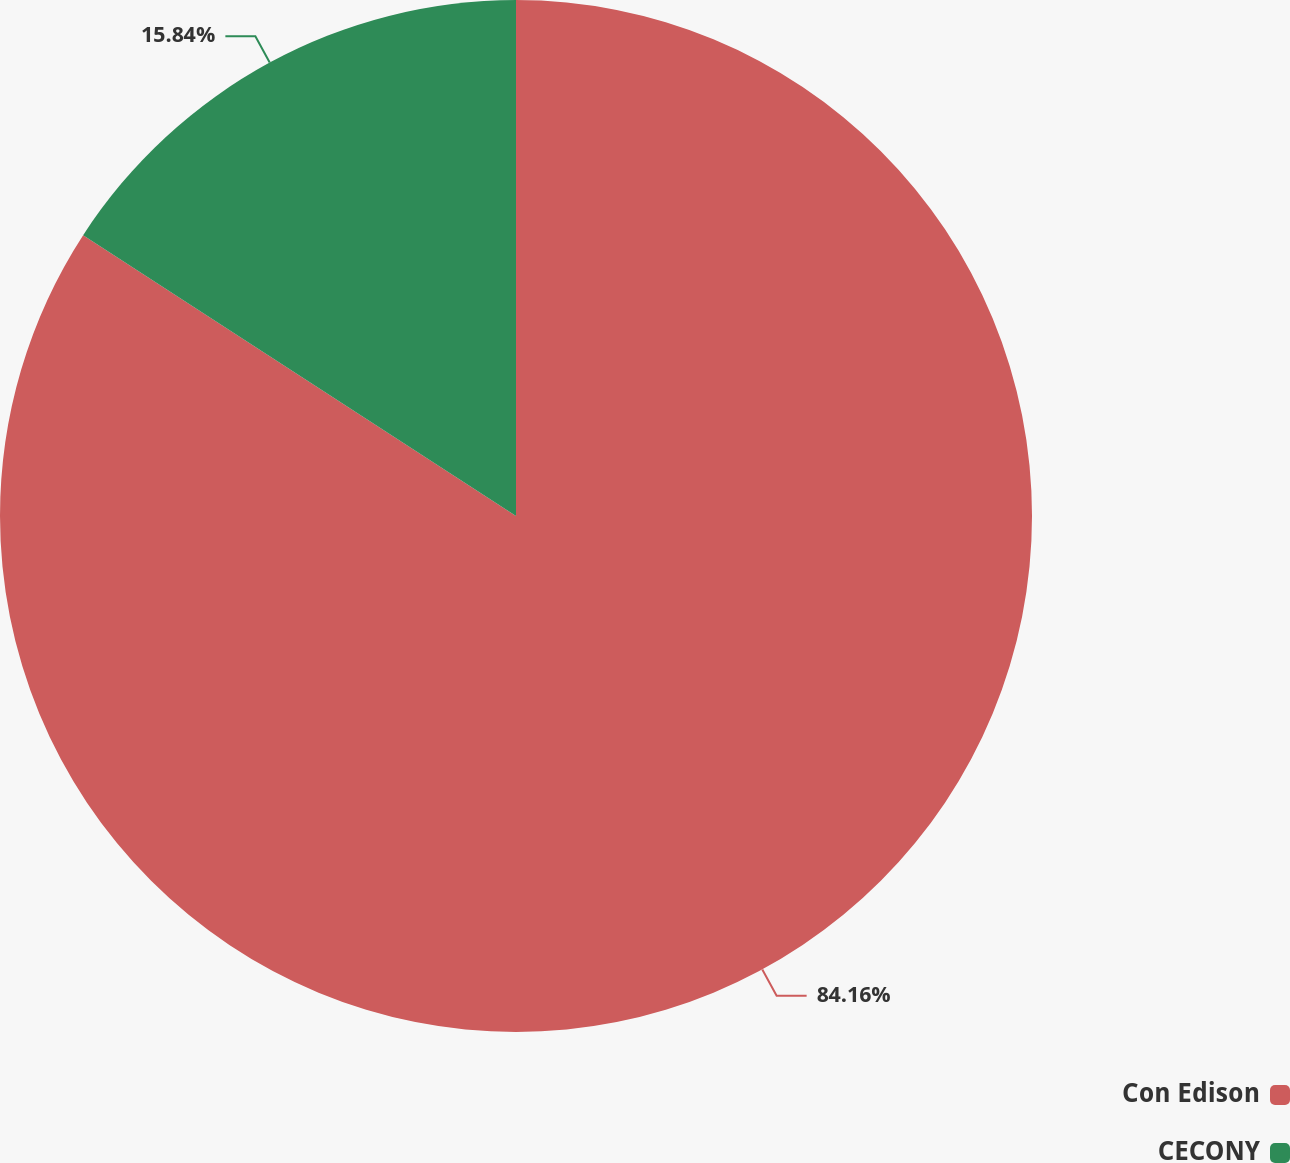Convert chart to OTSL. <chart><loc_0><loc_0><loc_500><loc_500><pie_chart><fcel>Con Edison<fcel>CECONY<nl><fcel>84.16%<fcel>15.84%<nl></chart> 